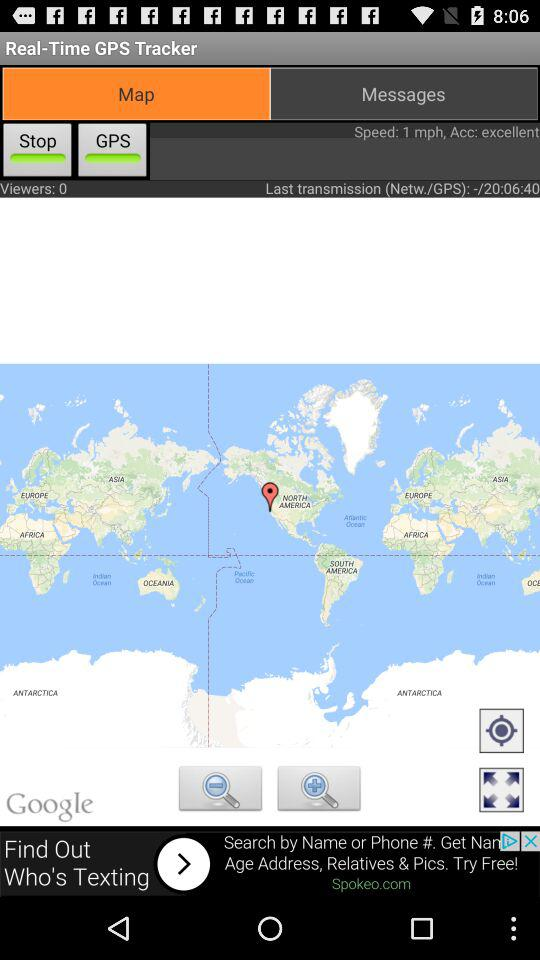Which tab is selected? The selected tab is "Map". 